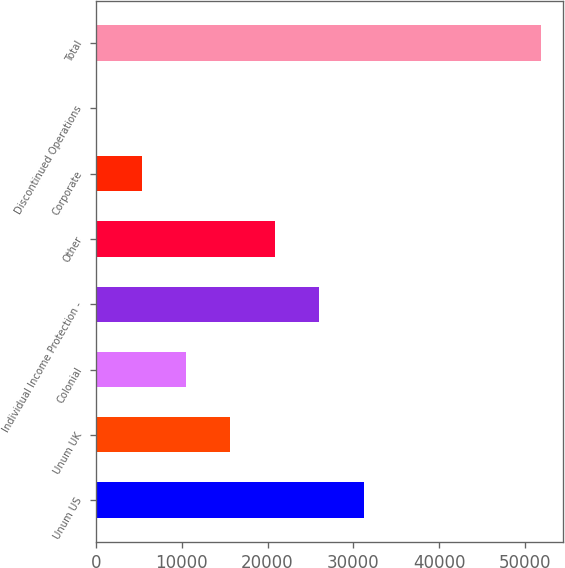Convert chart. <chart><loc_0><loc_0><loc_500><loc_500><bar_chart><fcel>Unum US<fcel>Unum UK<fcel>Colonial<fcel>Individual Income Protection -<fcel>Other<fcel>Corporate<fcel>Discontinued Operations<fcel>Total<nl><fcel>31185.2<fcel>15674.1<fcel>10503.7<fcel>26014.8<fcel>20844.5<fcel>5333.29<fcel>162.9<fcel>51866.8<nl></chart> 